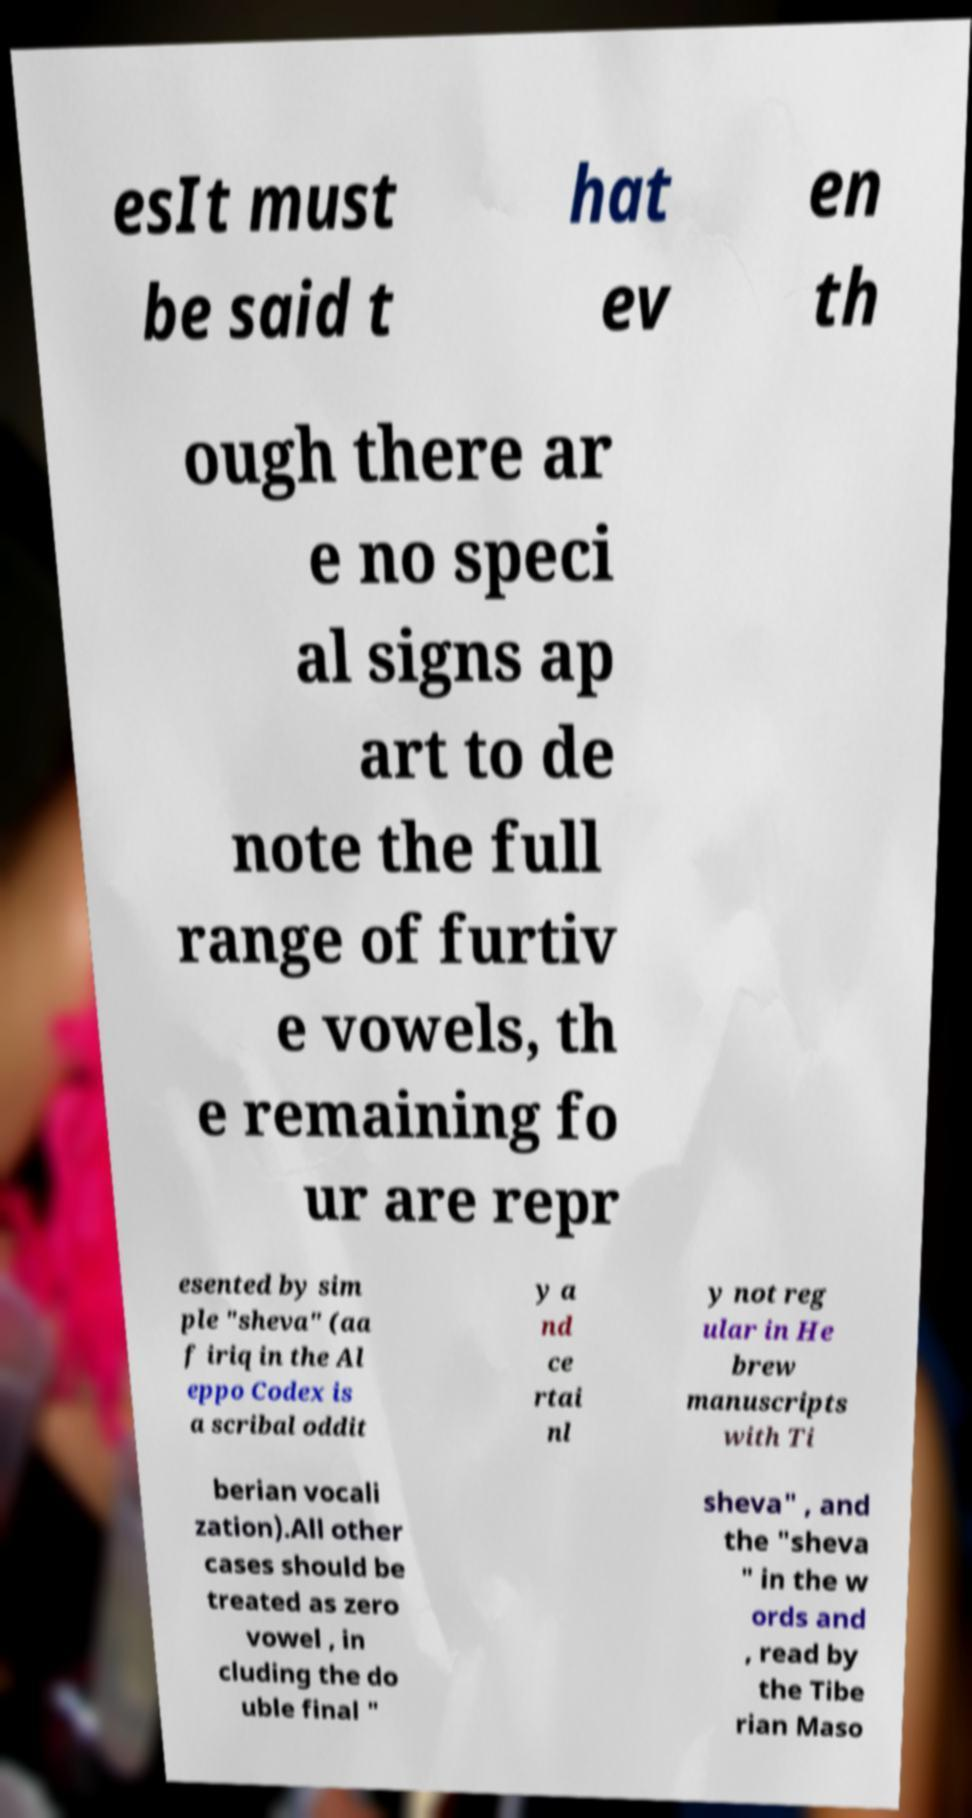Can you read and provide the text displayed in the image?This photo seems to have some interesting text. Can you extract and type it out for me? esIt must be said t hat ev en th ough there ar e no speci al signs ap art to de note the full range of furtiv e vowels, th e remaining fo ur are repr esented by sim ple "sheva" (aa f iriq in the Al eppo Codex is a scribal oddit y a nd ce rtai nl y not reg ular in He brew manuscripts with Ti berian vocali zation).All other cases should be treated as zero vowel , in cluding the do uble final " sheva" , and the "sheva " in the w ords and , read by the Tibe rian Maso 